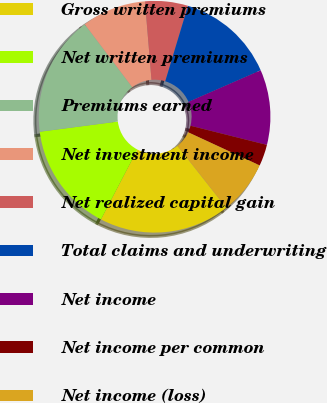<chart> <loc_0><loc_0><loc_500><loc_500><pie_chart><fcel>Gross written premiums<fcel>Net written premiums<fcel>Premiums earned<fcel>Net investment income<fcel>Net realized capital gain<fcel>Total claims and underwriting<fcel>Net income<fcel>Net income per common<fcel>Net income (loss)<nl><fcel>18.27%<fcel>15.28%<fcel>16.77%<fcel>8.97%<fcel>5.98%<fcel>13.78%<fcel>10.47%<fcel>2.99%<fcel>7.48%<nl></chart> 